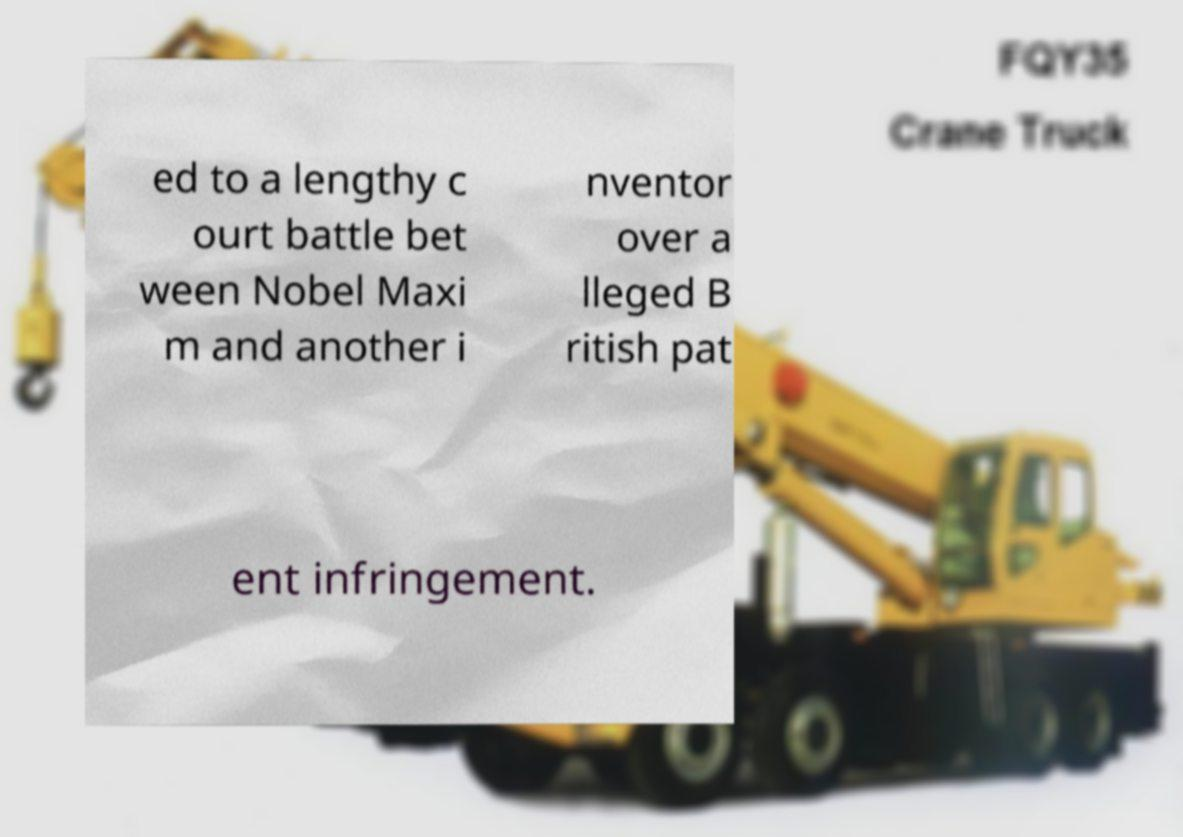What messages or text are displayed in this image? I need them in a readable, typed format. ed to a lengthy c ourt battle bet ween Nobel Maxi m and another i nventor over a lleged B ritish pat ent infringement. 